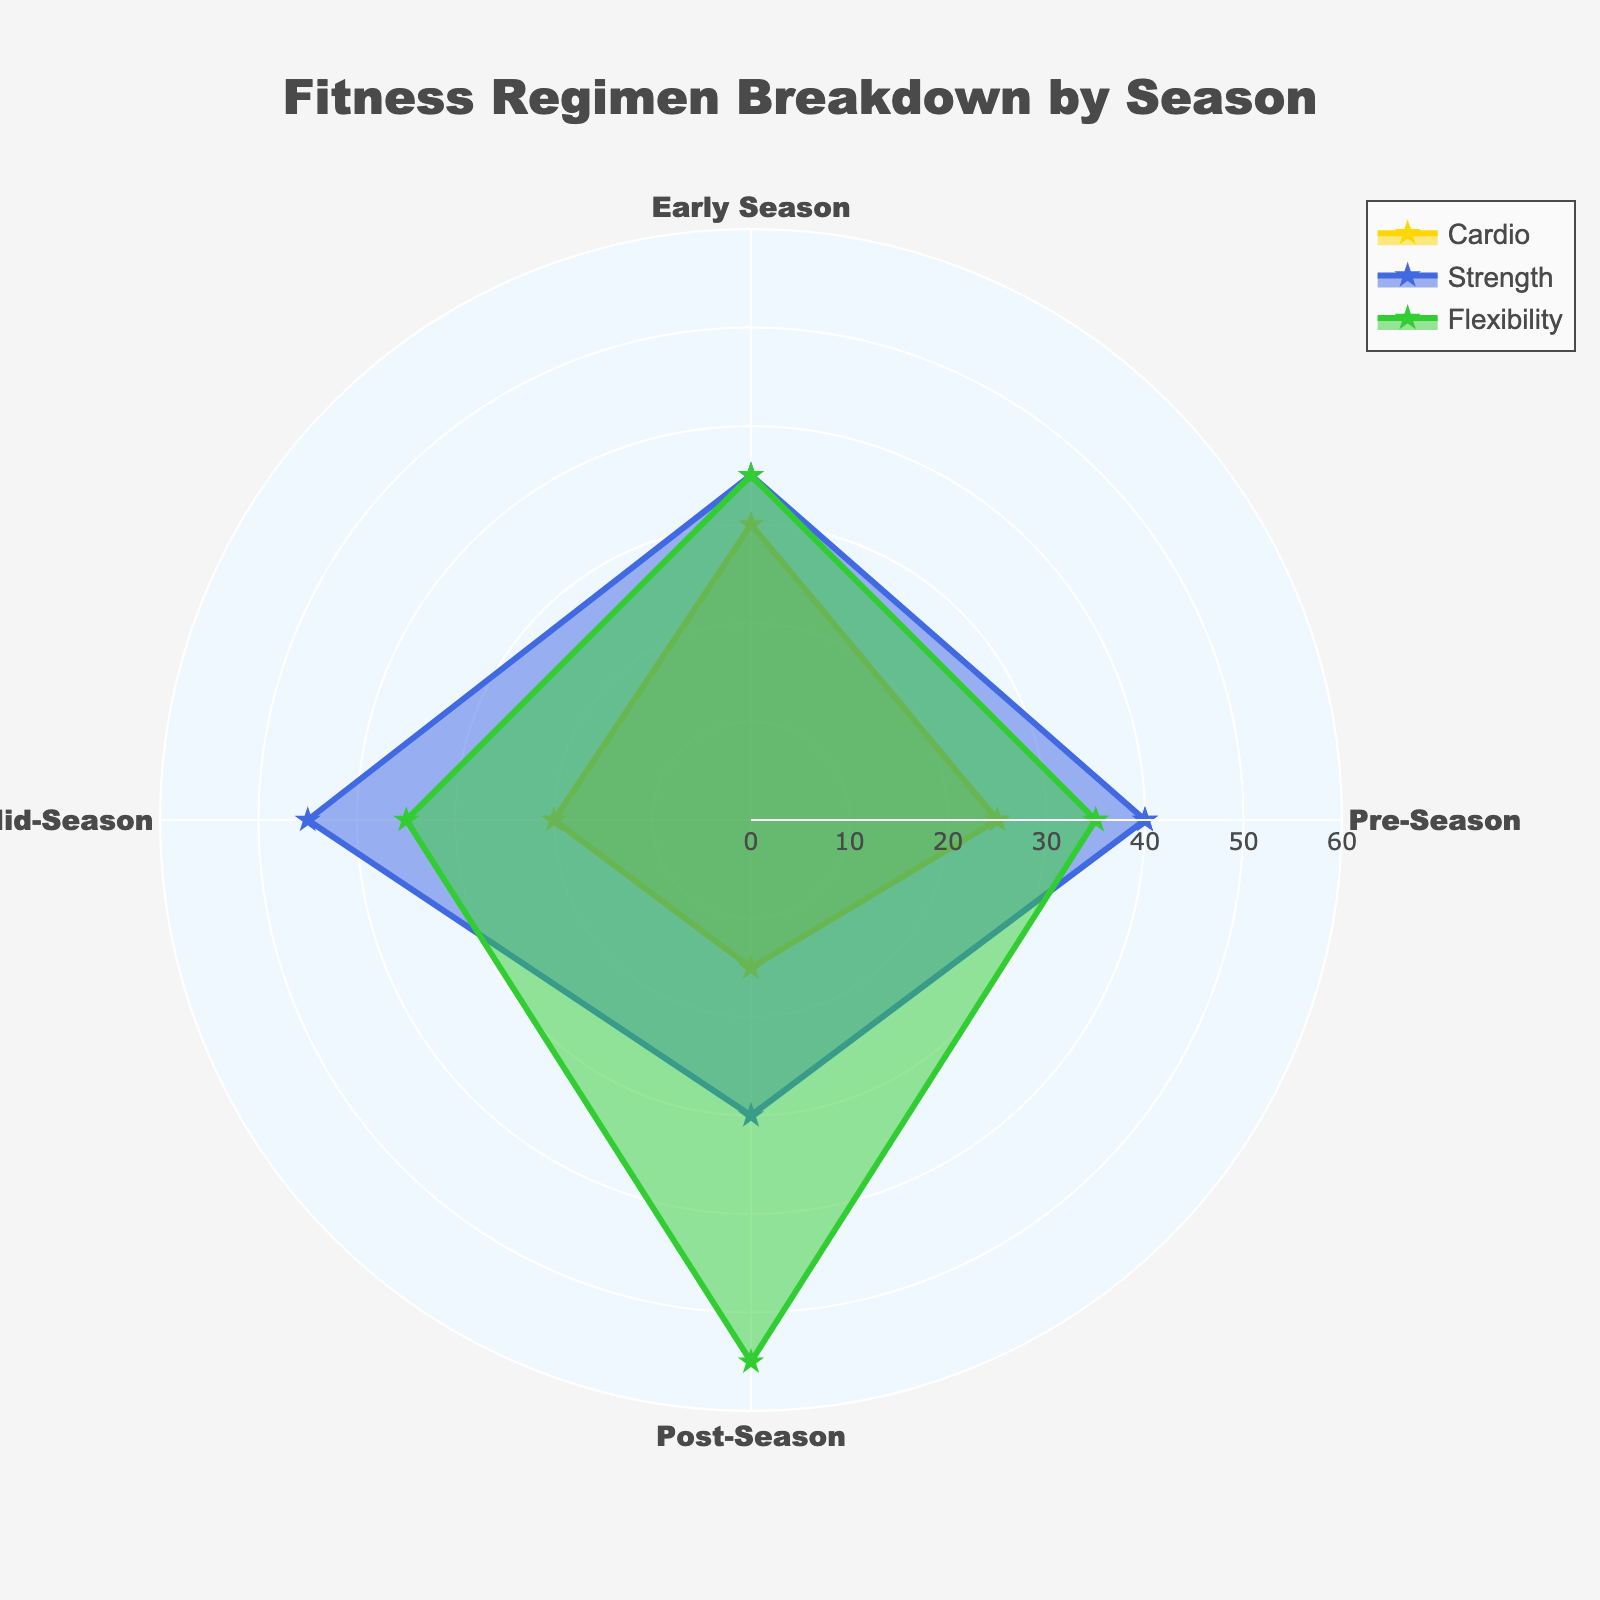What is the title of the figure? The title is typically displayed prominently at the top of the figure, indicating what the chart is about.
Answer: Fitness Regimen Breakdown by Season How many groups are shown in the radar chart? Inspecting the radial axes, we can see that there are four groups, each representing one season.
Answer: 4 Which season has the highest percentage of Flexibility training? By looking at the Flexibility data points, Post-Season has the highest value as its point is furthest from the center on the Flexibility axis.
Answer: Post-Season What are the values of Strength training in Early Season and Mid-Season? Locate the Strength points for Early Season and Mid-Season on the Strength axis, which are labeled accordingly.
Answer: 35, 45 What is the average percentage of Cardio training across all seasons? Sum the Cardio values (25 + 30 + 20 + 15) and divide by the number of seasons (4): (25+30+20+15)/4 = 22.5.
Answer: 22.5 Comparing Early Season and Post-Season, in which season is Cardio training more emphasized? Refer to the Cardio axis for Early Season and Post-Season; Early Season has a value of 30 whereas Post-Season has 15.
Answer: Early Season During which season does Flexibility training see no change compared to another season? Inspect the Flexibility axis; both Pre-Season and Early Season share the same value of 35.
Answer: Early Season, Pre-Season What's the combined percentage of Strength and Flexibility training for Mid-Season? Add the values for Strength (45) and Flexibility (35) for Mid-Season: 45+35 = 80.
Answer: 80 Is there any season where Strength training is not the highest or lowest fitness component? Inspect each season for Strength training values and compare them with Cardio and Flexibility. Most seasons have Strength as either highest or lowest except Pre-Season where it is neither, Flexibility is lower and Cardio is even lower.
Answer: Pre-Season What fitness component remains consistently the same for Pre-Season, Early Season, and Mid-Season, and what is its value? By analyzing the values, Flexibility remains the same for Pre-Season, Early Season, and Mid-Season, each showing the value of 35.
Answer: Flexibility, 35 